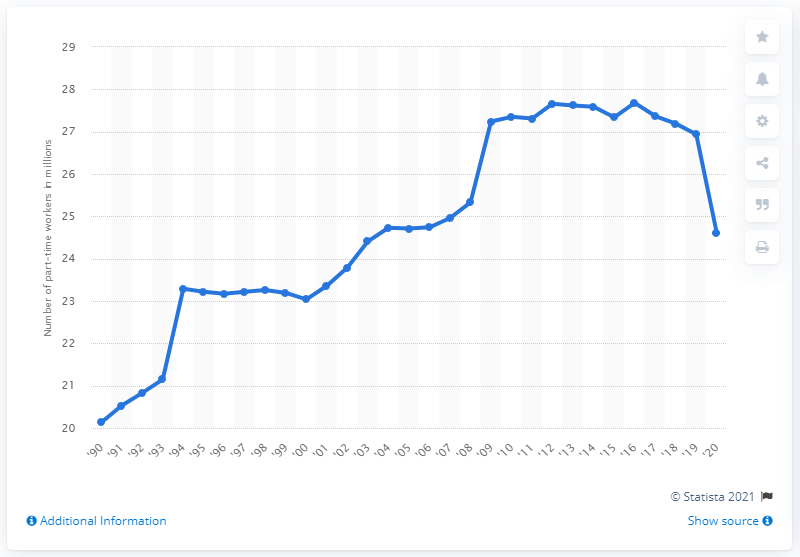Mention a couple of crucial points in this snapshot. In 2020, approximately 24.61 people were employed on a part-time basis. 